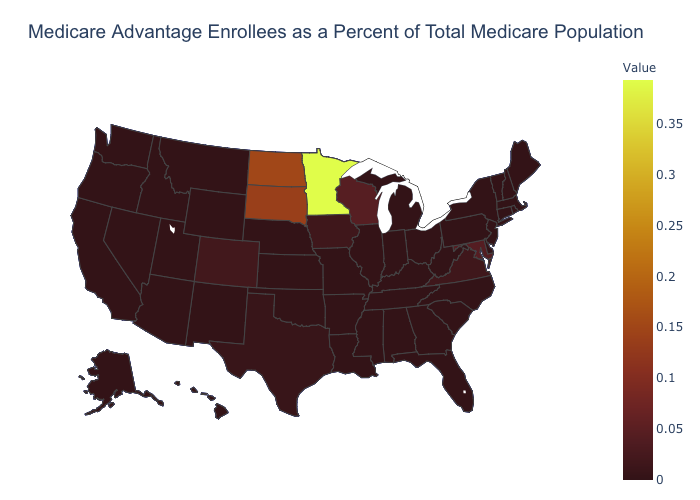Does Colorado have the highest value in the West?
Give a very brief answer. Yes. Among the states that border Colorado , which have the lowest value?
Short answer required. Kansas, Nebraska, New Mexico, Oklahoma, Utah, Wyoming. Which states have the lowest value in the West?
Give a very brief answer. Alaska, Hawaii, Idaho, Montana, Nevada, New Mexico, Oregon, Utah, Washington, Wyoming. Which states have the lowest value in the West?
Give a very brief answer. Alaska, Hawaii, Idaho, Montana, Nevada, New Mexico, Oregon, Utah, Washington, Wyoming. Among the states that border Louisiana , does Arkansas have the highest value?
Be succinct. No. Among the states that border Delaware , which have the lowest value?
Be succinct. New Jersey, Pennsylvania. 